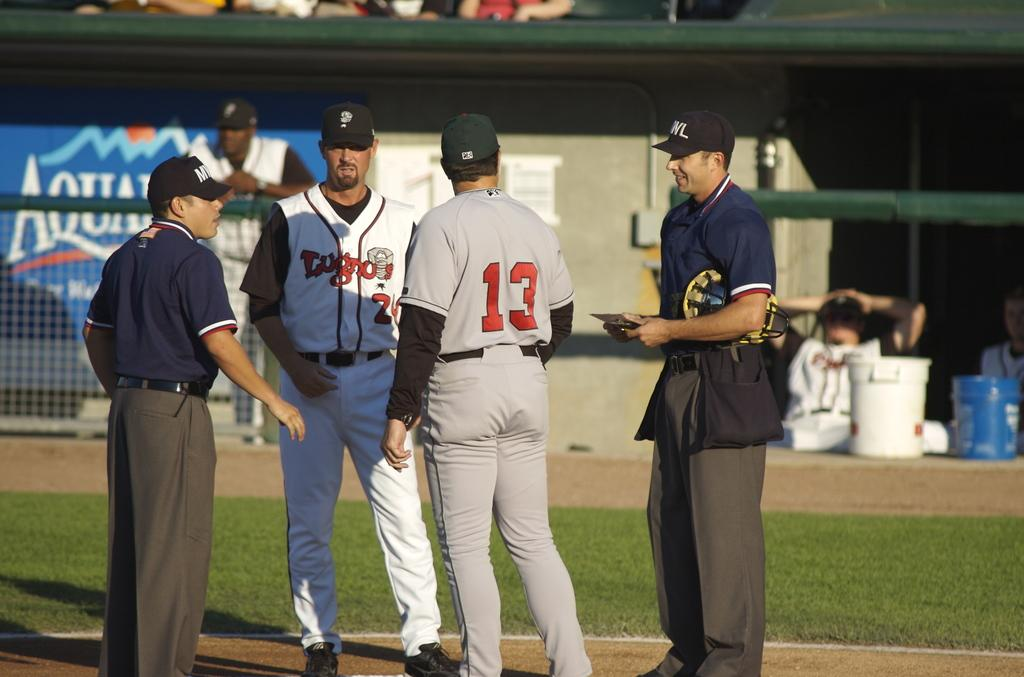Provide a one-sentence caption for the provided image. Player number 13 is walking over to confer with the referees. 